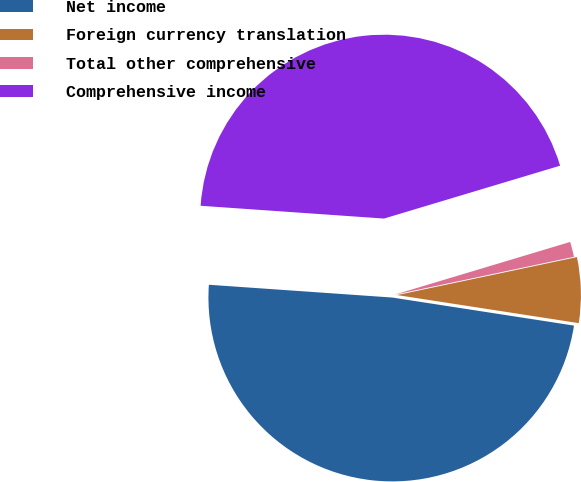Convert chart to OTSL. <chart><loc_0><loc_0><loc_500><loc_500><pie_chart><fcel>Net income<fcel>Foreign currency translation<fcel>Total other comprehensive<fcel>Comprehensive income<nl><fcel>48.67%<fcel>5.75%<fcel>1.33%<fcel>44.25%<nl></chart> 